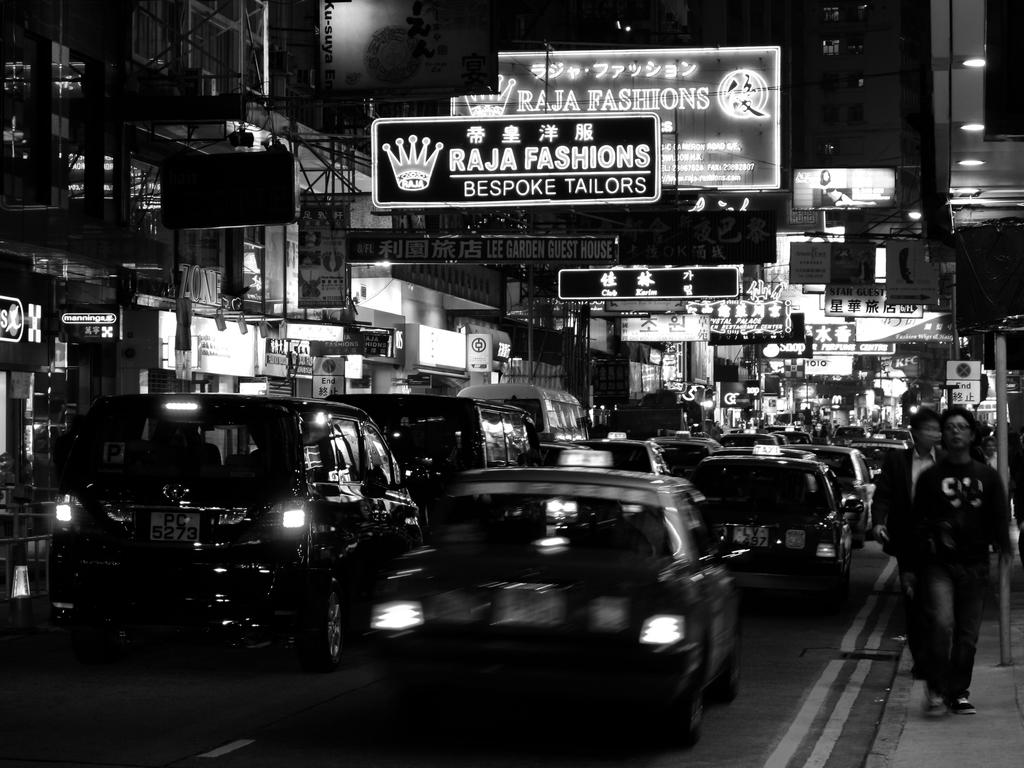<image>
Describe the image concisely. Cars on the street in the Raja Fashion Bespoke Tailors district 